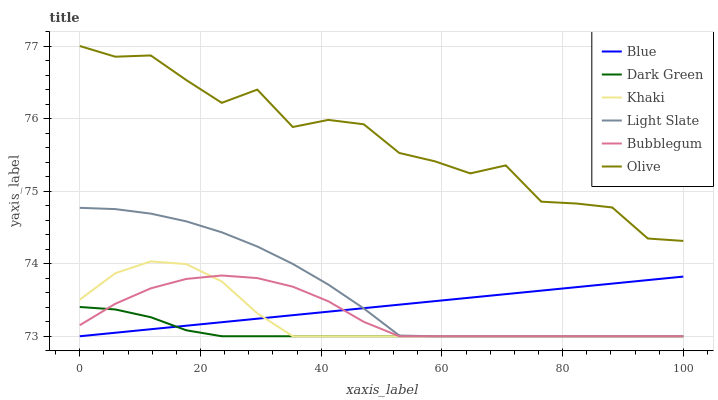Does Khaki have the minimum area under the curve?
Answer yes or no. No. Does Khaki have the maximum area under the curve?
Answer yes or no. No. Is Khaki the smoothest?
Answer yes or no. No. Is Khaki the roughest?
Answer yes or no. No. Does Olive have the lowest value?
Answer yes or no. No. Does Khaki have the highest value?
Answer yes or no. No. Is Light Slate less than Olive?
Answer yes or no. Yes. Is Olive greater than Khaki?
Answer yes or no. Yes. Does Light Slate intersect Olive?
Answer yes or no. No. 